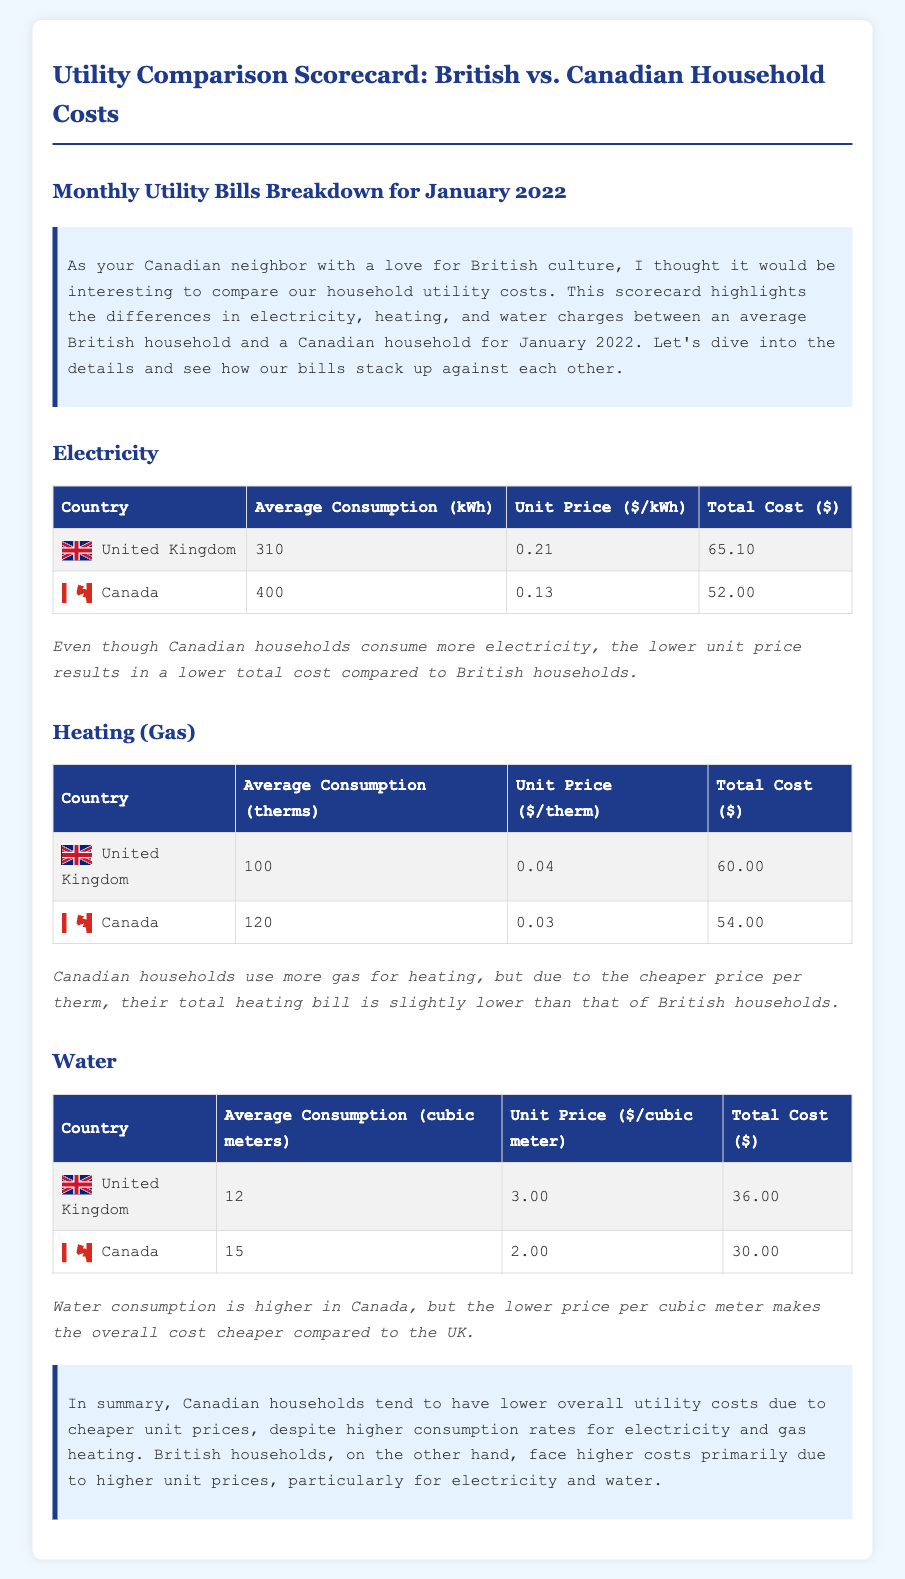What is the average electricity consumption in Canada? The average electricity consumption in Canada is 400 kWh according to the document.
Answer: 400 kWh What is the unit price of water in the United Kingdom? The unit price of water in the United Kingdom is $3.00 per cubic meter as stated in the scorecard.
Answer: $3.00 What is the total cost of heating for an average household in Canada? The total cost of heating for an average household in Canada is $54.00 based on the calculations provided.
Answer: $54.00 Which country has a higher average consumption of electricity? The comparison indicates that Canadian households have a higher average consumption of electricity at 400 kWh.
Answer: Canada What is the total cost of water in the UK? The document states that the total cost of water in the UK is $36.00.
Answer: $36.00 How does the unit price affect overall costs for electricity? The analysis shows that despite higher consumption in Canada, the lower unit price results in a lower total cost compared to the UK.
Answer: Lower total cost What is the average heating gas consumption in the UK? The average heating gas consumption in the United Kingdom is 100 therms as per the table provided.
Answer: 100 therms Which household has a lower total utility cost overall according to the scorecard? The document concludes that Canadian households have lower overall utility costs due to cheaper unit prices.
Answer: Canadian households What is the monthly utility comparison scorecard focusing on? The scorecard focuses on monthly utility bills breakdown for electricity, heating, and water charges between British and Canadian households.
Answer: Utility bills comparison 